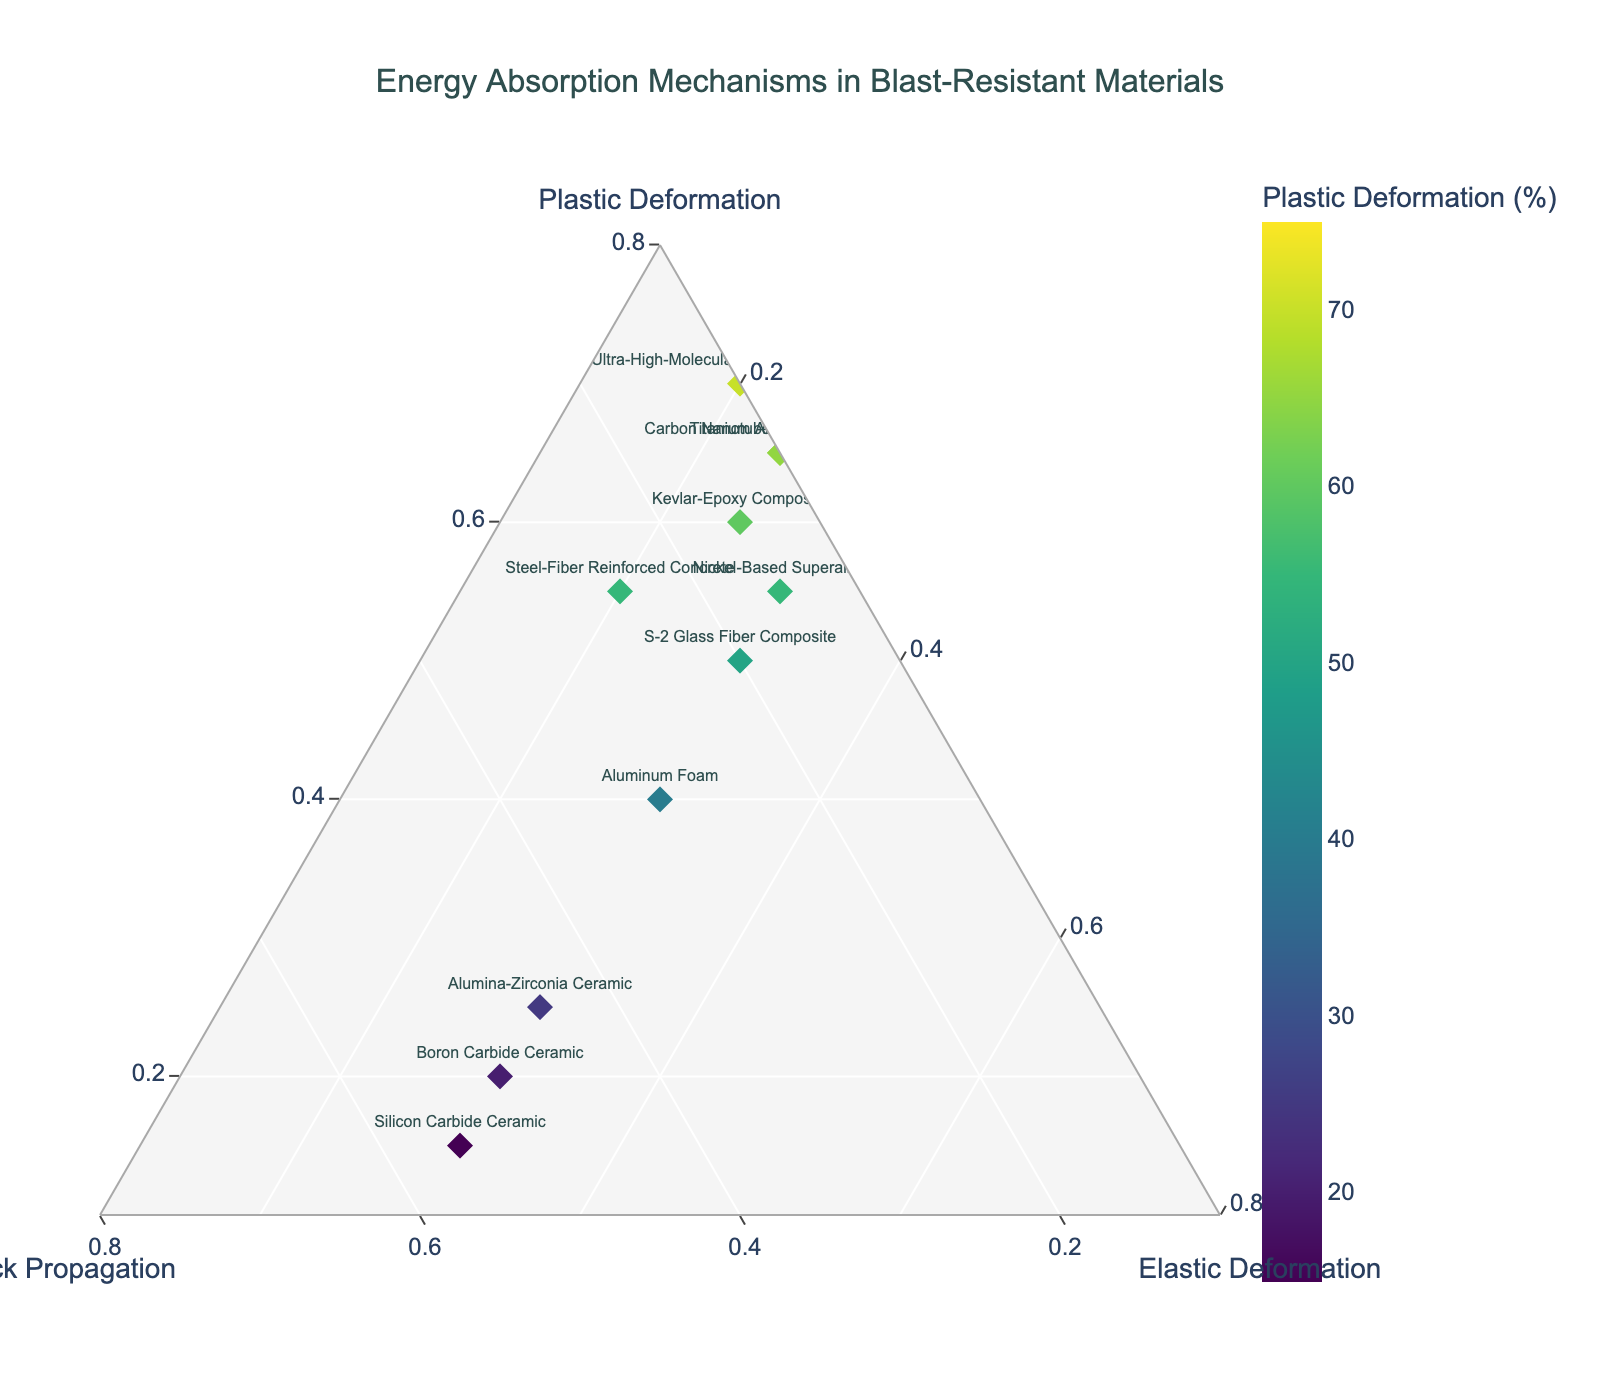What is the title of the figure? The title of a figure is typically placed prominently at the top. In this case, it's displayed clearly.
Answer: Energy Absorption Mechanisms in Blast-Resistant Materials How many materials are represented in the figure? Count the number of unique data points labeled with material names in the ternary plot.
Answer: 12 Which material has the highest percentage of plastic deformation? Look for the material whose marker is the darkest in color, as the color intensity represents plastic deformation percentage.
Answer: Dyneema Fiber Laminate Which materials have equal percentages of elastic deformation? Locate the materials at the same position along the elastic deformation axis.
Answer: Boron Carbide Ceramic, Alumina-Zirconia Ceramic, S-2 Glass Fiber Composite, Silicon Carbide Ceramic, Nickel-Based Superalloy, Aluminum Foam What is the median percentage of plastic deformation across all materials? List out the plastic deformation percentages, sort them, and find the middle value(s). The percentages are: 15, 20, 20, 25, 25, 30, 30, 45, 50, 55, 55, 60, 65, 70, 75. As there is an even number of data points, the median is the average of the two middle values (55+55)/2.
Answer: 55 Which material shows the least reliance on crack propagation for energy absorption? Identify the material positioned closest to the opposite side of the crack propagation axis.
Answer: Dyneema Fiber Laminate How do the percentages of energy absorption mechanisms compare between Kevlar-Epoxy Composite and Ultra-High-Molecular-Weight Polyethylene? Compare the values corresponding to plastic deformation, crack propagation, and elastic deformation for both materials. Kevlar-Epoxy Composite: 60%, 15%, 25%. Ultra-High-Molecular-Weight Polyethylene: 70%, 10%, 20%.
Answer: UHM-Polyethylene has higher plastic deformation and lower crack propagation than Kevlar-Epoxy Which two materials have the closest percentages of crack propagation? Examine the positions along the crack propagation axis and identify the pairs closest to each other. Boron Carbide Ceramic: 50%, Alumina-Zirconia Ceramic: 45%.
Answer: Boron Carbide Ceramic and Alumina-Zirconia Ceramic What is the average percentage of elastic deformation among all ceramics listed? Identify all ceramic materials, sum their elastic deformation percentages, and divide by the number of ceramics. Ceramics are Boron Carbide: 30%, Alumina-Zirconia: 30%, Silicon Carbide: 30%. Average = (30 + 30 + 30) / 3.
Answer: 30 Which material has a balanced distribution of the three energy absorption mechanisms? Identify the material closest to the centroid of the ternary plot, where plastic deformation, crack propagation, and elastic deformation are equal.
Answer: Aluminum Foam 